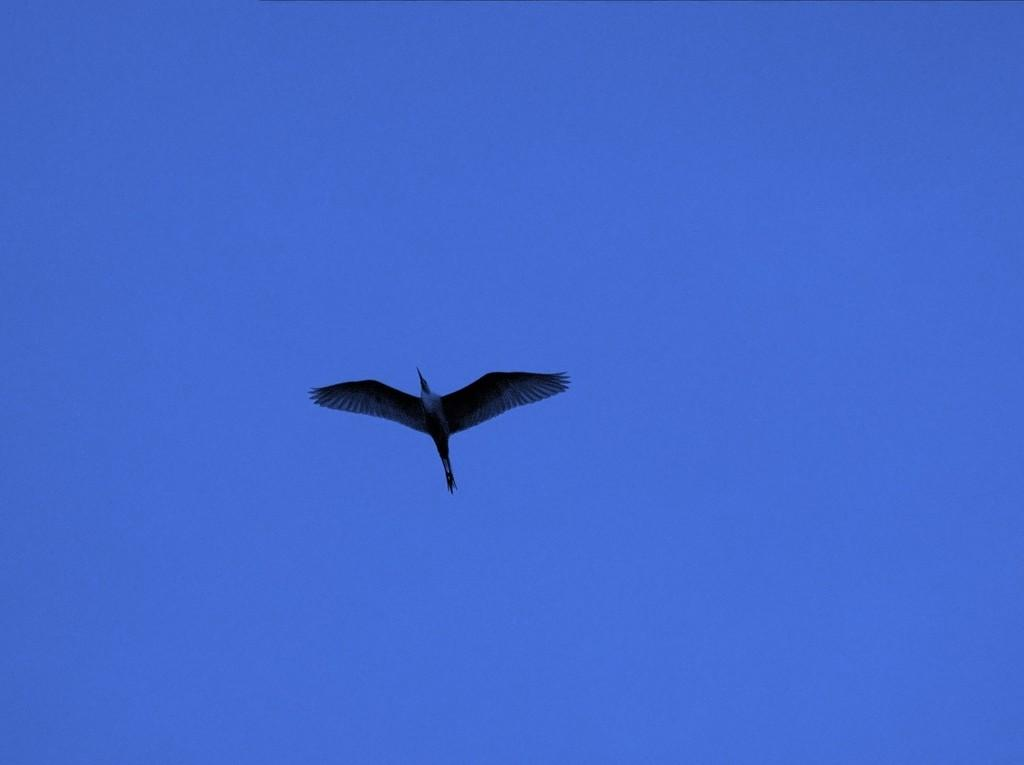What is the main subject of the image? The main subject of the image is a bird flying in the air. What can be seen in the background of the image? The sky is visible in the image and has a blue color. What type of breakfast is the bird eating in the image? There is no breakfast present in the image, as it features a bird flying in the air. How does the bird sort the items in the image? There are no items to sort in the image, as it only features a bird flying in the air. 